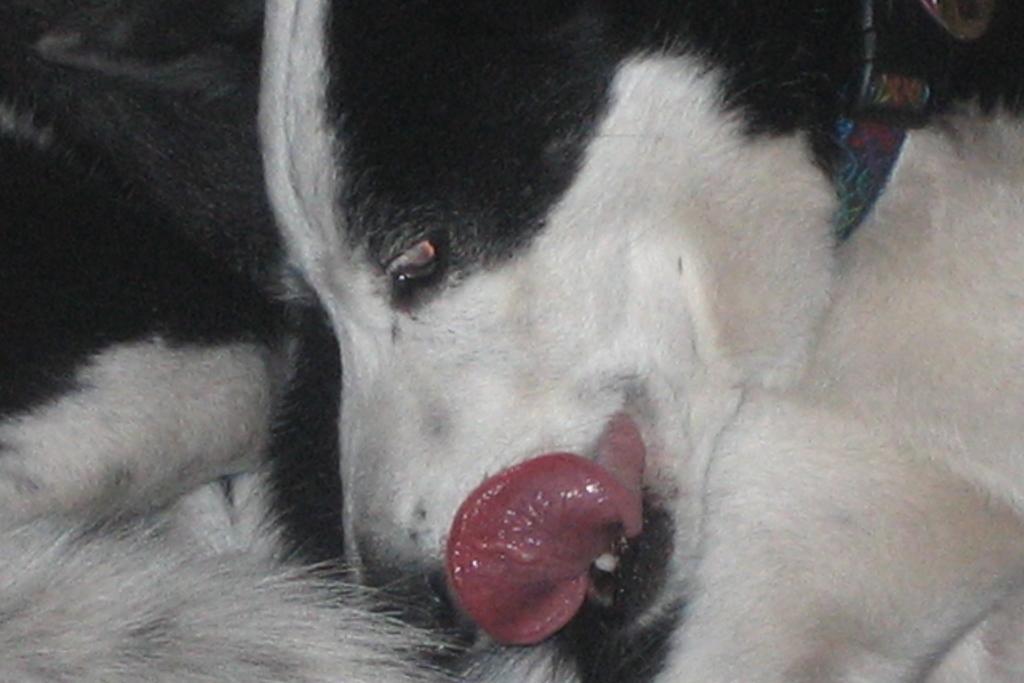How would you summarize this image in a sentence or two? In this image, we can see a white and black color dog. 